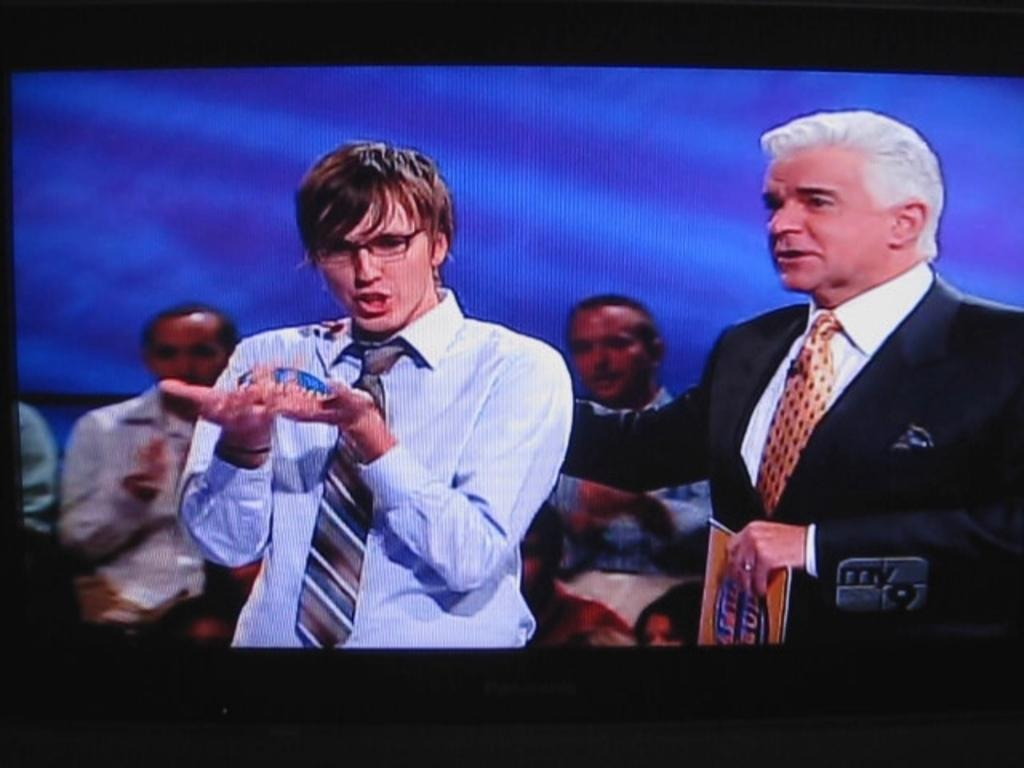<image>
Provide a brief description of the given image. Game show contestant is shown with the word My in the corner. 